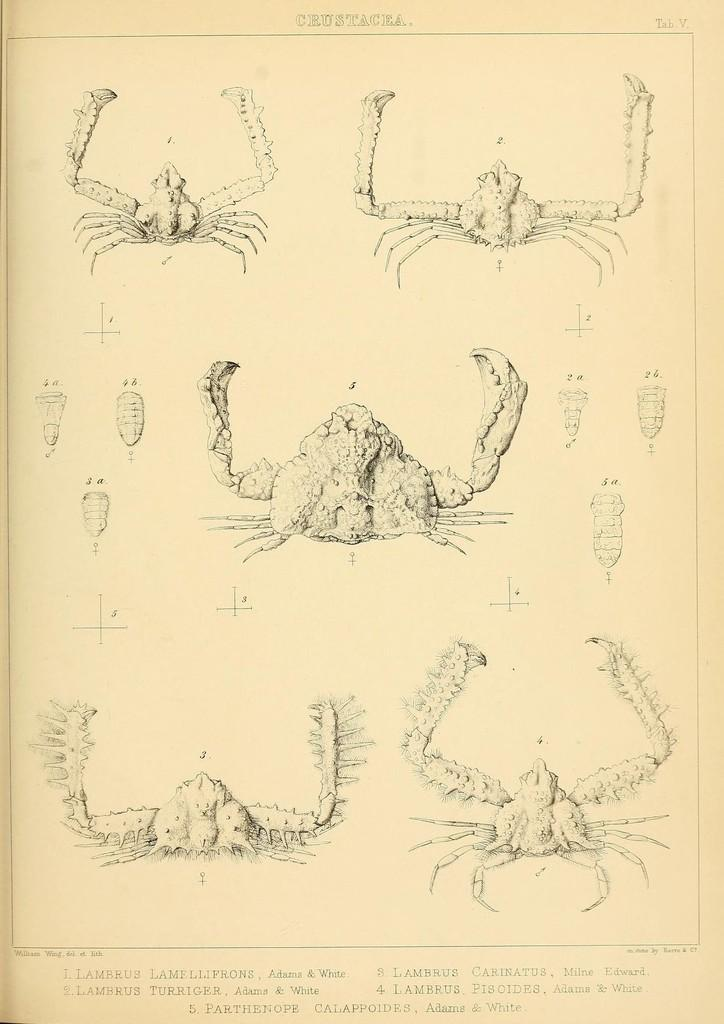What is present in the image related to written or visual communication? There is a paper in the image that contains arts and text. Can you describe the content of the paper in the image? The paper contains arts and text. What type of arts can be seen on the paper? The facts provided do not specify the type of arts on the paper. What is the son's desire for the faucet in the image? There is no son or faucet present in the image, so it is not possible to answer that question. 